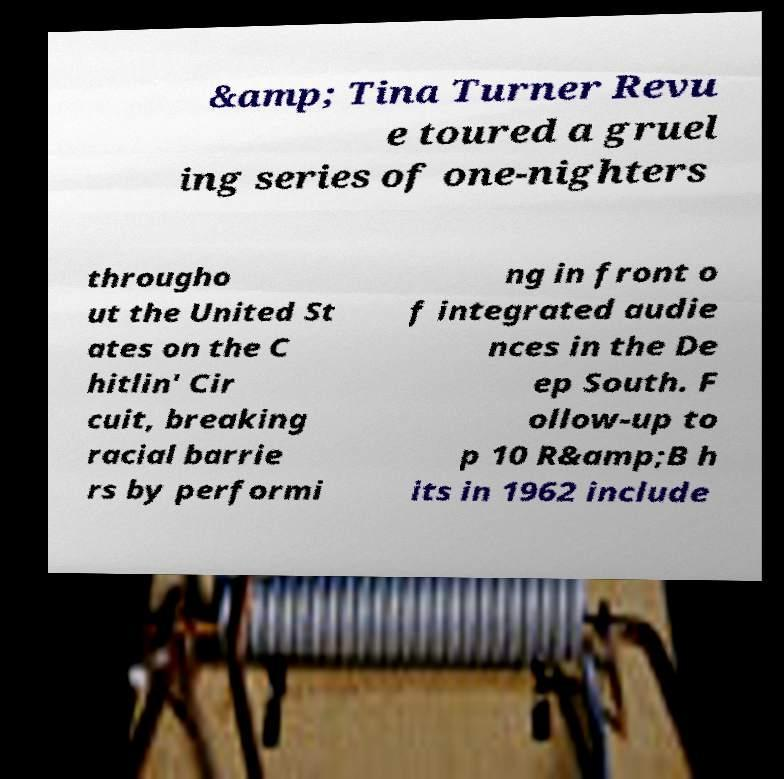Please identify and transcribe the text found in this image. &amp; Tina Turner Revu e toured a gruel ing series of one-nighters througho ut the United St ates on the C hitlin' Cir cuit, breaking racial barrie rs by performi ng in front o f integrated audie nces in the De ep South. F ollow-up to p 10 R&amp;B h its in 1962 include 